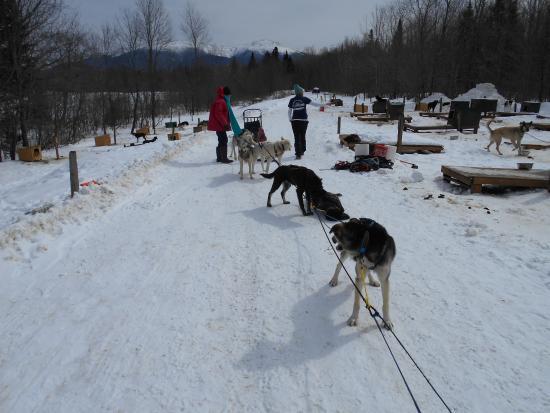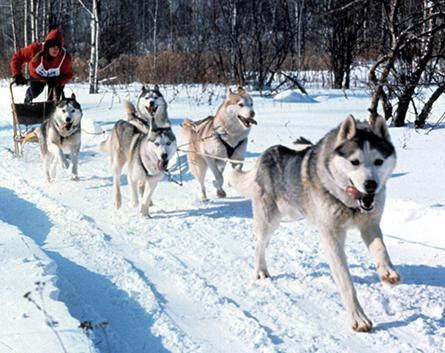The first image is the image on the left, the second image is the image on the right. Analyze the images presented: Is the assertion "There is at least one person wearing a red coat in the image on the right." valid? Answer yes or no. Yes. 